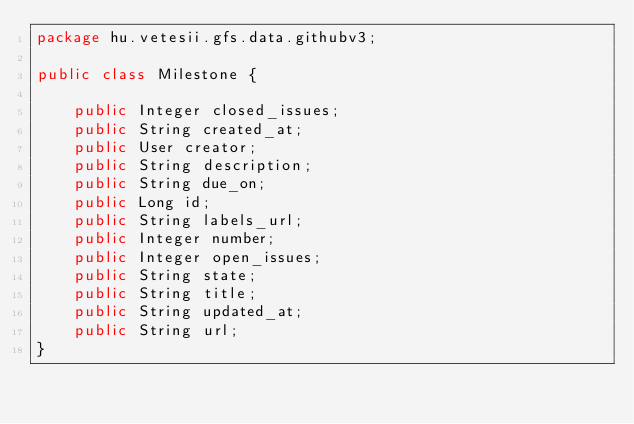Convert code to text. <code><loc_0><loc_0><loc_500><loc_500><_Java_>package hu.vetesii.gfs.data.githubv3;

public class Milestone {

    public Integer closed_issues;
    public String created_at;
    public User creator;
    public String description;
    public String due_on;
    public Long id;
    public String labels_url;
    public Integer number;
    public Integer open_issues;
    public String state;
    public String title;
    public String updated_at;
    public String url;
}
</code> 